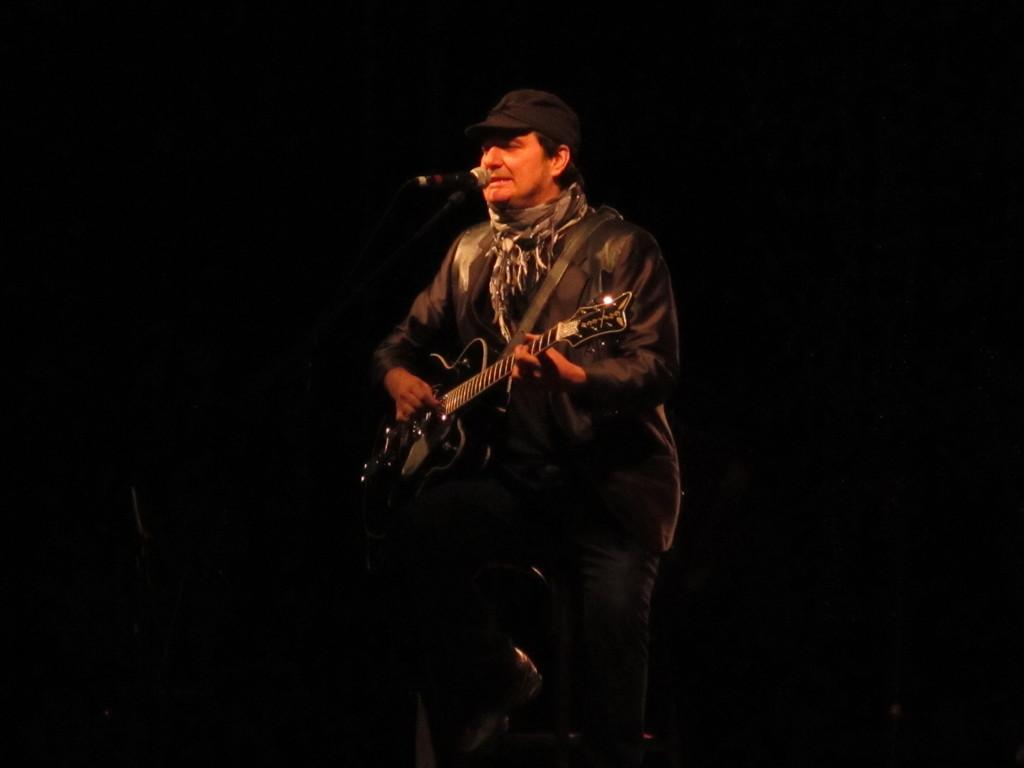What is the man in the image wearing? The man is wearing a black suit, a grey scarf, and a black cap on his head. What is the man doing in the image? The man is playing a guitar. What object is in front of the man? There is a microphone in front of the man. How many tickets does the man have in his hand in the image? There is no indication in the image that the man has any tickets in his hand. What type of expert is the man in the image? The image does not provide any information about the man's expertise or profession. 